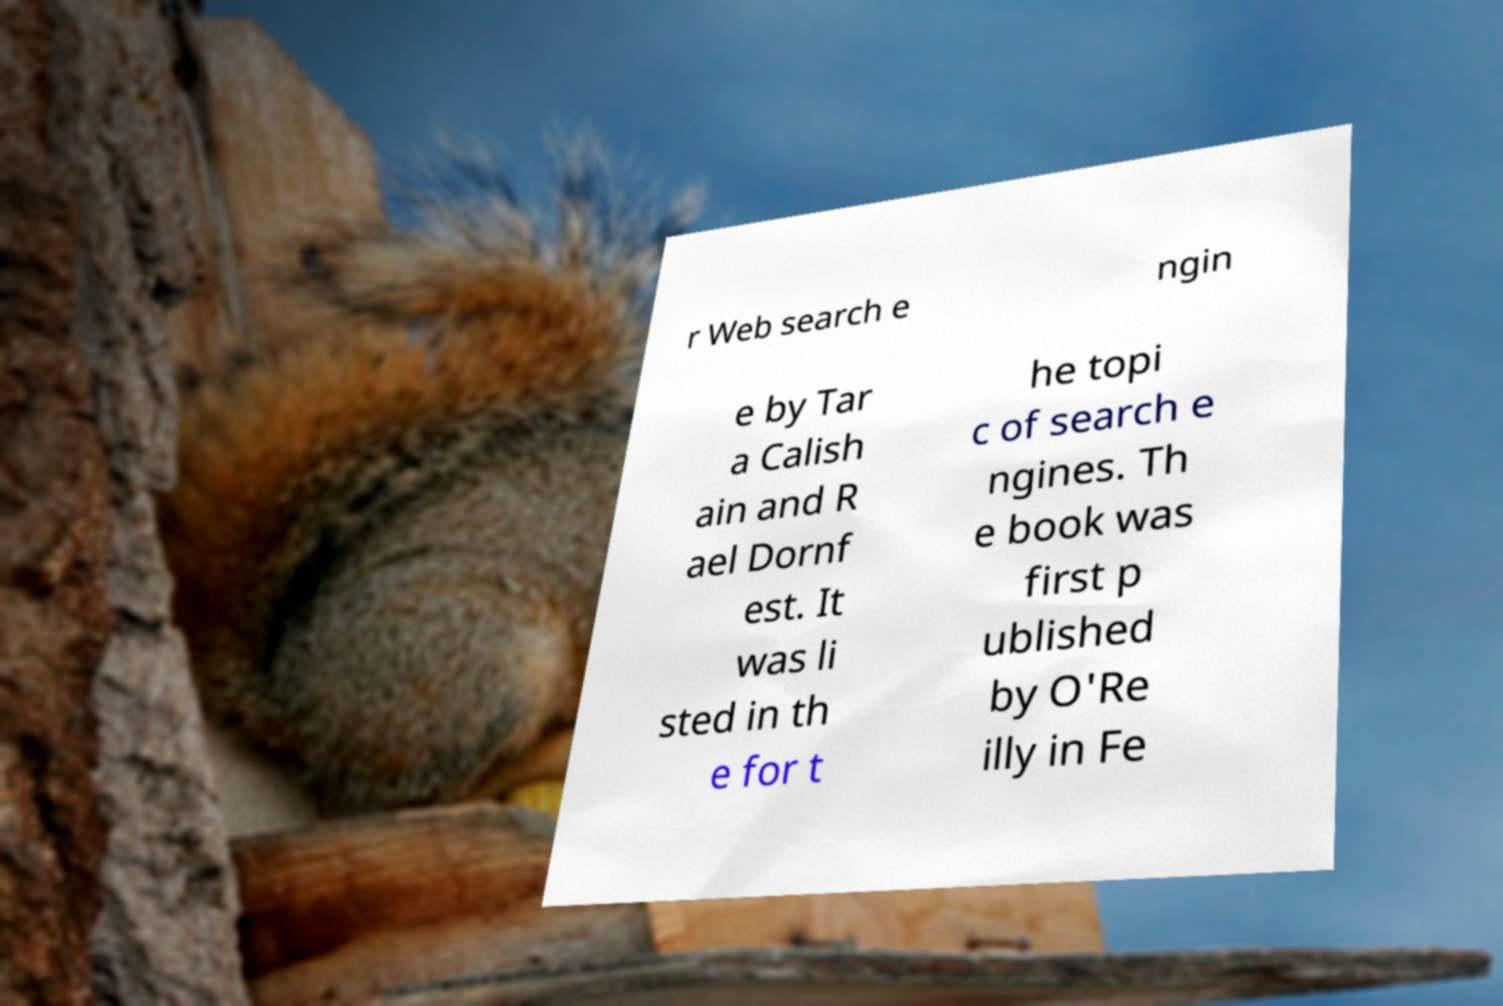I need the written content from this picture converted into text. Can you do that? r Web search e ngin e by Tar a Calish ain and R ael Dornf est. It was li sted in th e for t he topi c of search e ngines. Th e book was first p ublished by O'Re illy in Fe 